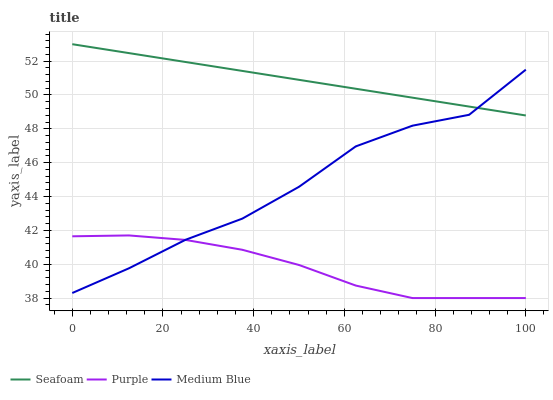Does Purple have the minimum area under the curve?
Answer yes or no. Yes. Does Seafoam have the maximum area under the curve?
Answer yes or no. Yes. Does Medium Blue have the minimum area under the curve?
Answer yes or no. No. Does Medium Blue have the maximum area under the curve?
Answer yes or no. No. Is Seafoam the smoothest?
Answer yes or no. Yes. Is Medium Blue the roughest?
Answer yes or no. Yes. Is Medium Blue the smoothest?
Answer yes or no. No. Is Seafoam the roughest?
Answer yes or no. No. Does Purple have the lowest value?
Answer yes or no. Yes. Does Medium Blue have the lowest value?
Answer yes or no. No. Does Seafoam have the highest value?
Answer yes or no. Yes. Does Medium Blue have the highest value?
Answer yes or no. No. Is Purple less than Seafoam?
Answer yes or no. Yes. Is Seafoam greater than Purple?
Answer yes or no. Yes. Does Medium Blue intersect Seafoam?
Answer yes or no. Yes. Is Medium Blue less than Seafoam?
Answer yes or no. No. Is Medium Blue greater than Seafoam?
Answer yes or no. No. Does Purple intersect Seafoam?
Answer yes or no. No. 